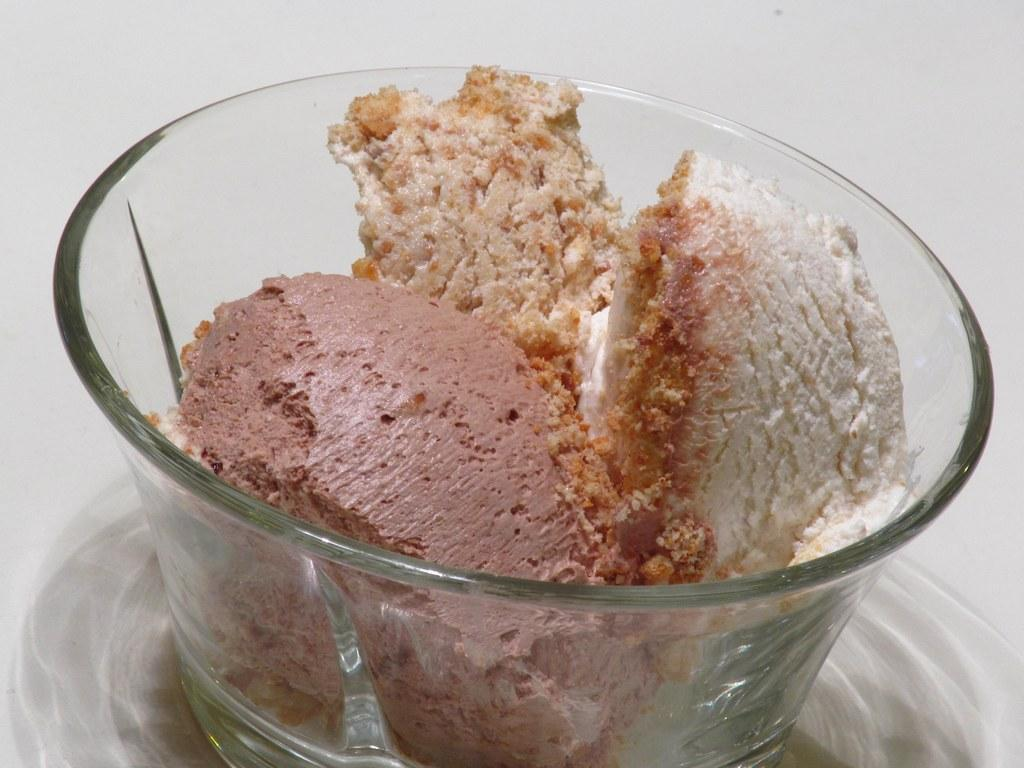What type of container is visible in the image? There is a glass bowl in the image. What is inside the container? There is food in the bowl. Can you describe the background of the image? The background of the image features a plane. How many cattle can be seen grazing in the image? There are no cattle present in the image. What is the elbow's role in the image? There is no elbow mentioned or depicted in the image. 